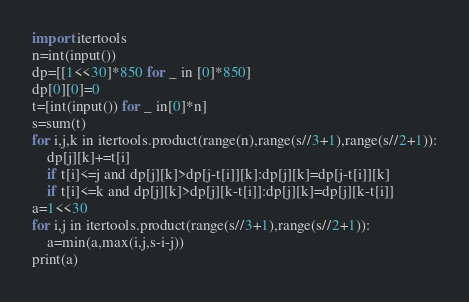Convert code to text. <code><loc_0><loc_0><loc_500><loc_500><_Python_>import itertools
n=int(input())
dp=[[1<<30]*850 for _ in [0]*850]
dp[0][0]=0
t=[int(input()) for _ in[0]*n]
s=sum(t)
for i,j,k in itertools.product(range(n),range(s//3+1),range(s//2+1)):
    dp[j][k]+=t[i]
    if t[i]<=j and dp[j][k]>dp[j-t[i]][k]:dp[j][k]=dp[j-t[i]][k]
    if t[i]<=k and dp[j][k]>dp[j][k-t[i]]:dp[j][k]=dp[j][k-t[i]]
a=1<<30
for i,j in itertools.product(range(s//3+1),range(s//2+1)):
    a=min(a,max(i,j,s-i-j))
print(a)</code> 